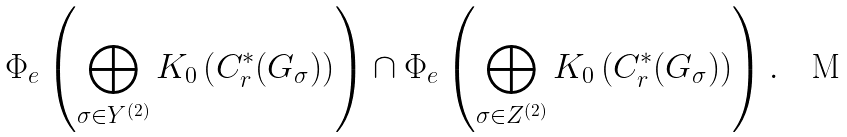<formula> <loc_0><loc_0><loc_500><loc_500>\Phi _ { e } \left ( \bigoplus _ { \sigma \in Y ^ { ( 2 ) } } K _ { 0 } \left ( C ^ { * } _ { r } ( G _ { \sigma } ) \right ) \right ) \cap \Phi _ { e } \left ( \bigoplus _ { \sigma \in Z ^ { ( 2 ) } } K _ { 0 } \left ( C ^ { * } _ { r } ( G _ { \sigma } ) \right ) \right ) .</formula> 